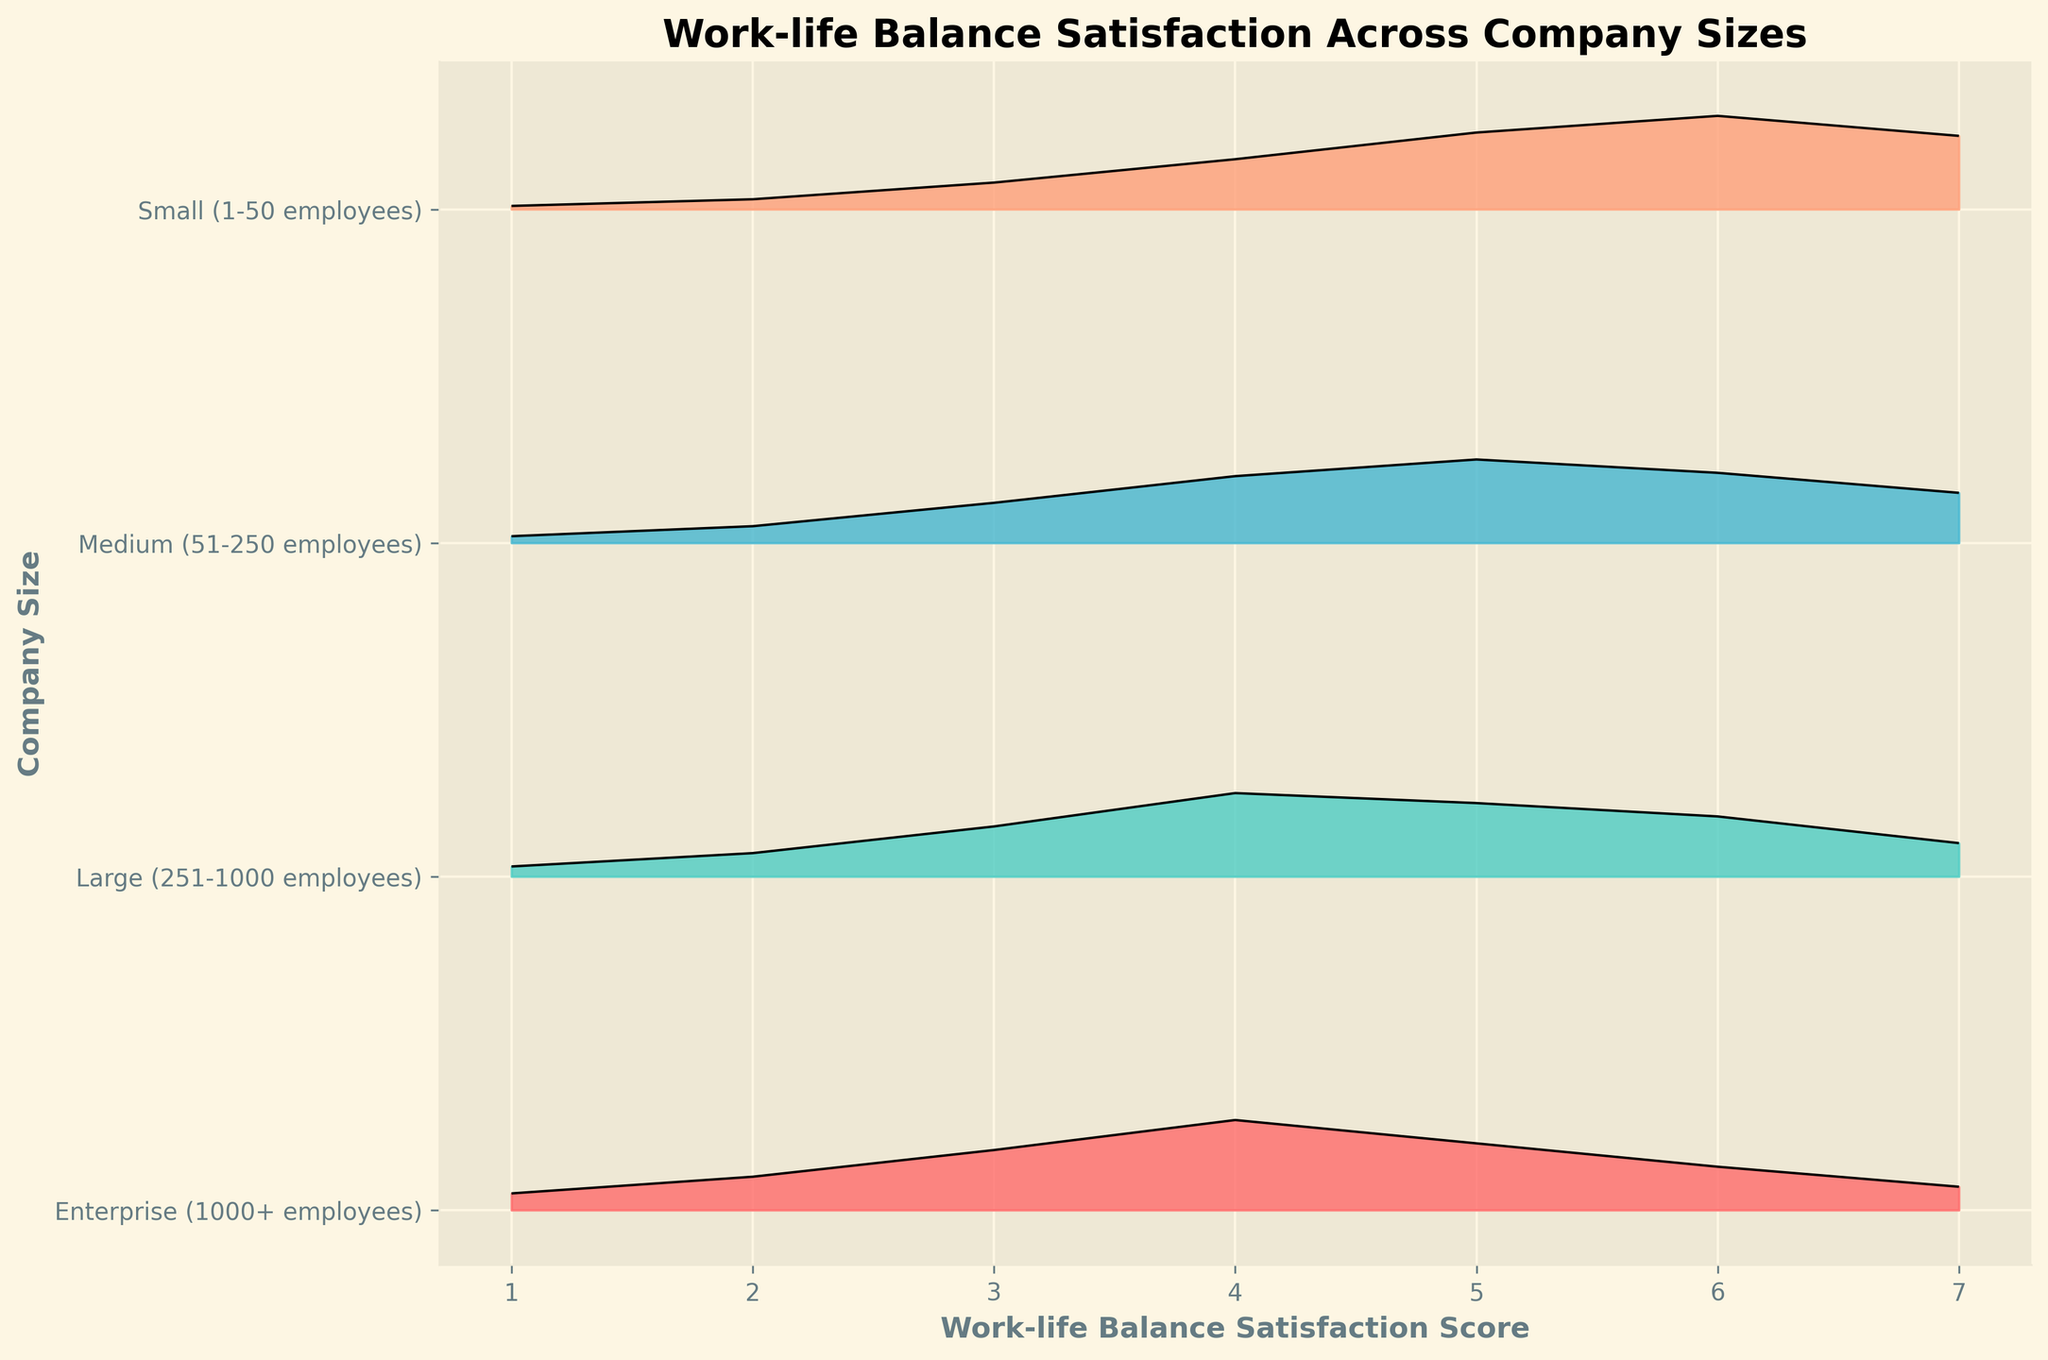What is the title of the figure? The title of the diagram is presented at the top of the plot and clearly states the data being visualized.
Answer: Work-life Balance Satisfaction Across Company Sizes Which company size has the highest peak density in work-life balance satisfaction scores? Scan the plot and identify the peak of each ridgeline. The company size with the highest peak is the one whose ridgeline reaches the tallest on the y-axis.
Answer: Small (1-50 employees) What work-life balance satisfaction score corresponds to the highest peak density for the 'Small' company size? Look at the highest point on the ridgeline for the 'Small' company size and see which score it aligns with on the x-axis.
Answer: 6 Which company size shows the highest density at a satisfaction score of 4? Identify the ridgeline that is highest over the score 4 on the x-axis.
Answer: Enterprise (1000+ employees) Which company size appears to have the least variability in work-life balance satisfaction scores? Look for the ridgeline that is the least spread out, indicating scores are more concentrated around a central value.
Answer: Large (251-1000 employees) What trend do you notice in the work-life balance satisfaction scores as company size increases from 'Small' to 'Enterprise'? Observe the ridgelines from 'Small' to 'Enterprise' and note the pattern in the distribution of their peaks and spreads.
Answer: Peaks shift left and spread widens, indicating less satisfaction For 'Medium' companies, which score has the second-highest density? Identify the second-highest point along the ridgeline for the 'Medium' companies and see which score it aligns with on the x-axis.
Answer: 5 Compare the density at score 1 between 'Small' and 'Enterprise' companies. Which is higher? Look at the density values corresponding to score 1 for both 'Small' and 'Enterprise' ridgelines and compare their heights.
Answer: Enterprise (1000+ employees) What is the general trend in the maximum density as company size increases? Look at the highest point of each ridgeline, starting from 'Small' to 'Enterprise', and note the trend.
Answer: Decreases Assuming higher density indicates higher satisfaction, which company size is generally more satisfied with their work-life balance? Compare the height and position of the peak densities of all company sizes.
Answer: Small (1-50 employees) 